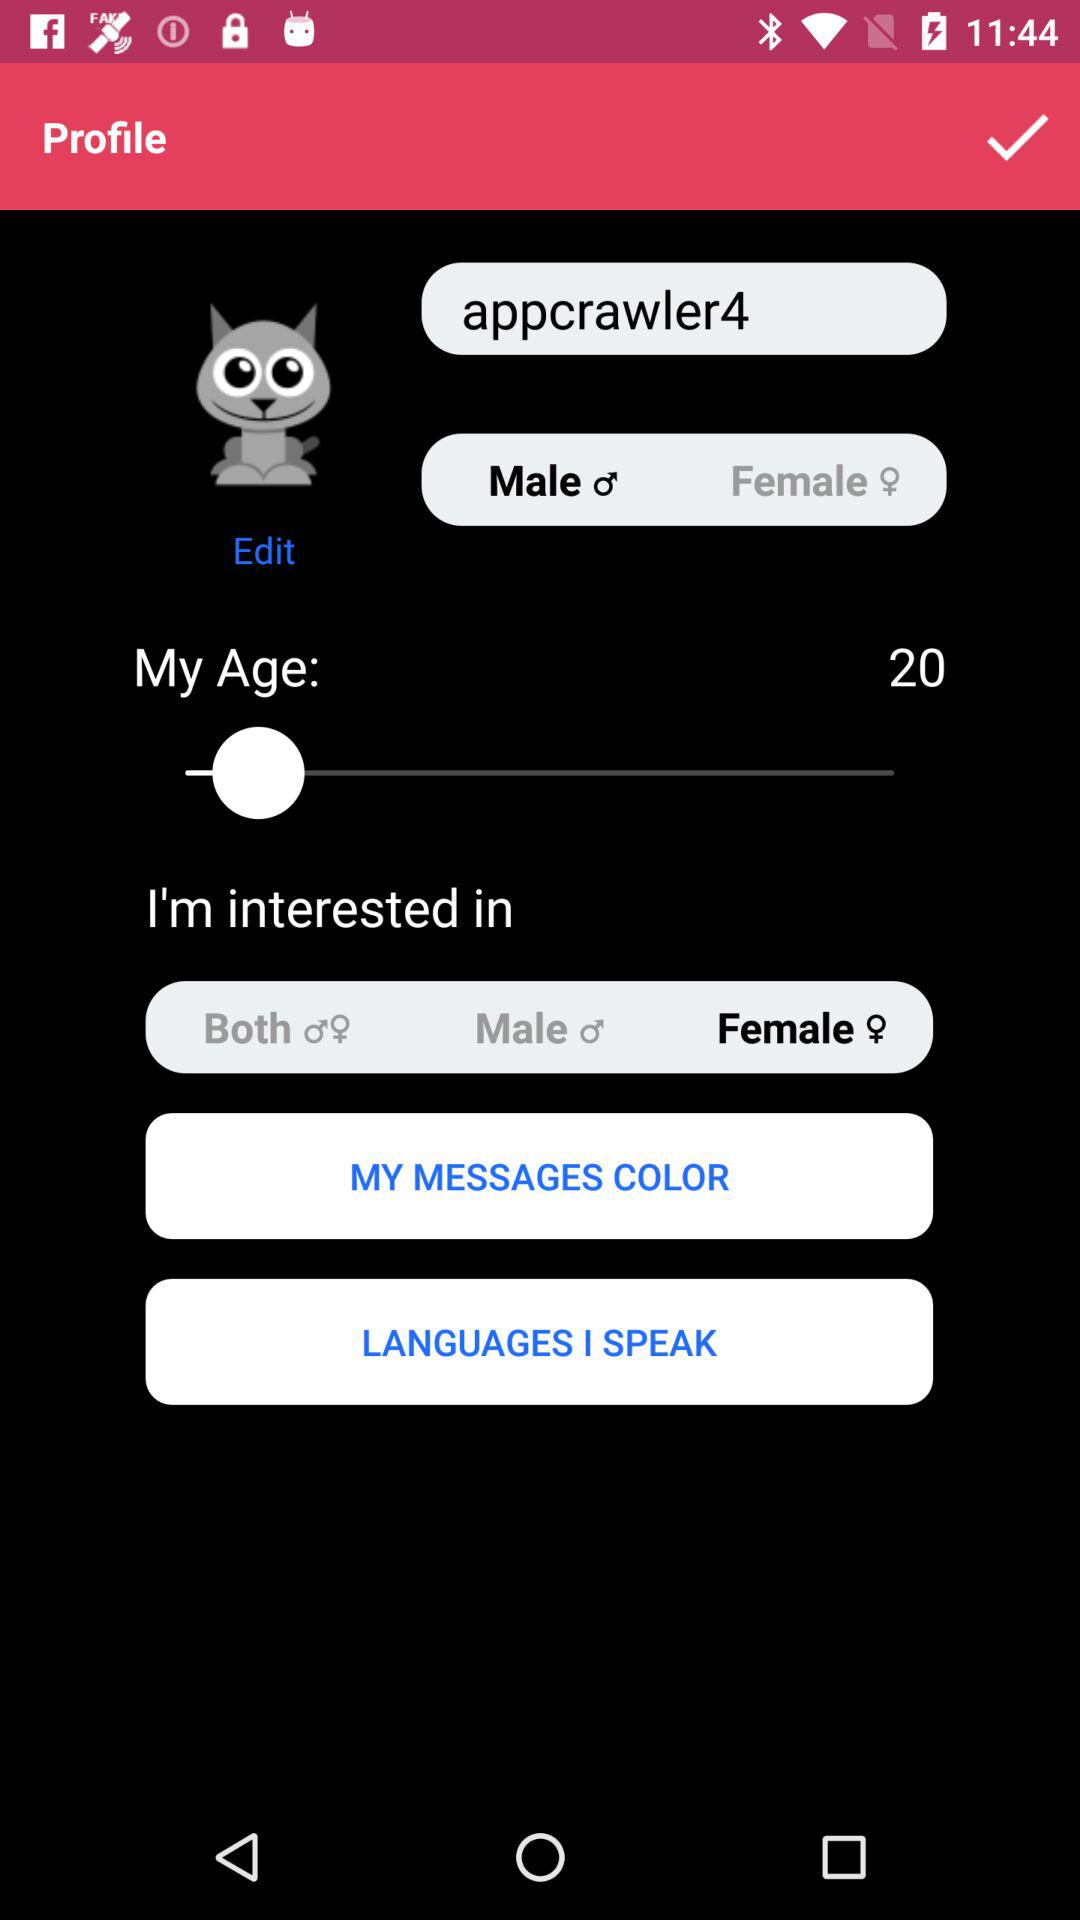What is the username? The username is appcrawler4. 